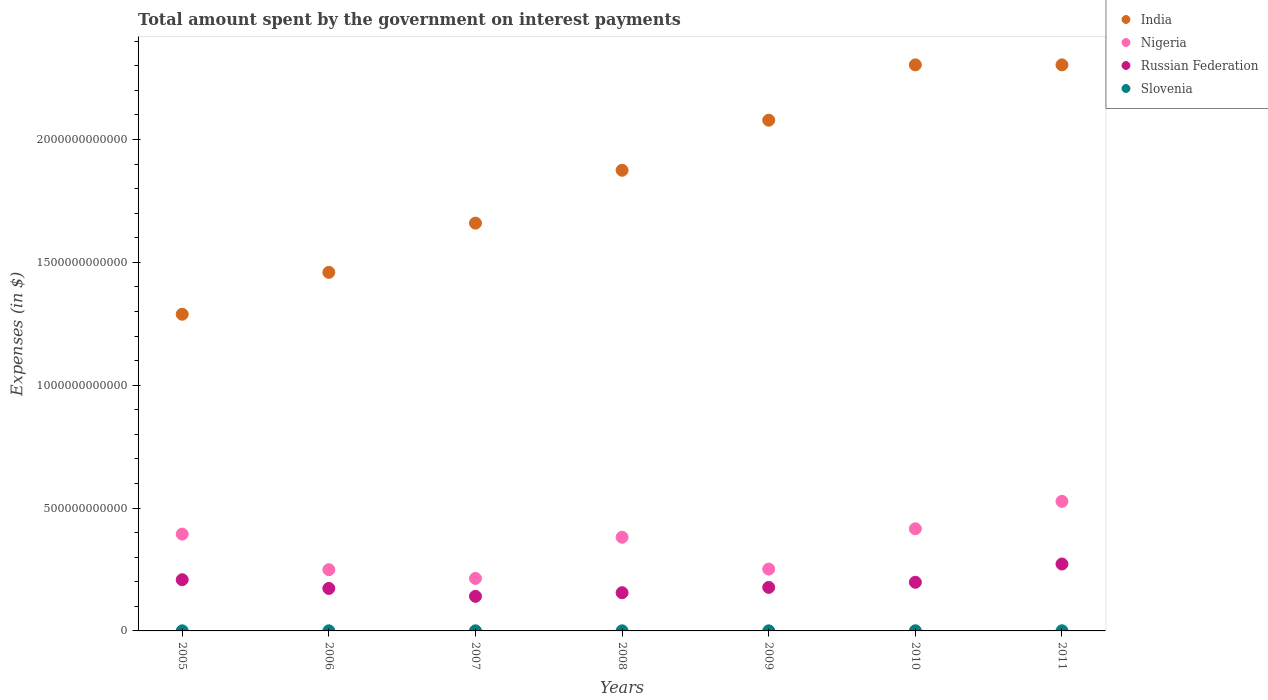How many different coloured dotlines are there?
Your answer should be very brief. 4. Is the number of dotlines equal to the number of legend labels?
Give a very brief answer. Yes. What is the amount spent on interest payments by the government in Russian Federation in 2011?
Offer a very short reply. 2.72e+11. Across all years, what is the maximum amount spent on interest payments by the government in India?
Keep it short and to the point. 2.30e+12. Across all years, what is the minimum amount spent on interest payments by the government in Russian Federation?
Provide a succinct answer. 1.41e+11. In which year was the amount spent on interest payments by the government in Nigeria maximum?
Ensure brevity in your answer.  2011. What is the total amount spent on interest payments by the government in India in the graph?
Offer a very short reply. 1.30e+13. What is the difference between the amount spent on interest payments by the government in Nigeria in 2005 and that in 2010?
Offer a very short reply. -2.17e+1. What is the difference between the amount spent on interest payments by the government in Nigeria in 2006 and the amount spent on interest payments by the government in Slovenia in 2010?
Ensure brevity in your answer.  2.49e+11. What is the average amount spent on interest payments by the government in India per year?
Offer a very short reply. 1.85e+12. In the year 2009, what is the difference between the amount spent on interest payments by the government in Russian Federation and amount spent on interest payments by the government in Slovenia?
Provide a succinct answer. 1.77e+11. In how many years, is the amount spent on interest payments by the government in Nigeria greater than 1300000000000 $?
Keep it short and to the point. 0. What is the ratio of the amount spent on interest payments by the government in Russian Federation in 2005 to that in 2007?
Provide a succinct answer. 1.48. Is the difference between the amount spent on interest payments by the government in Russian Federation in 2005 and 2009 greater than the difference between the amount spent on interest payments by the government in Slovenia in 2005 and 2009?
Your answer should be very brief. Yes. What is the difference between the highest and the second highest amount spent on interest payments by the government in India?
Keep it short and to the point. 0. What is the difference between the highest and the lowest amount spent on interest payments by the government in India?
Provide a succinct answer. 1.01e+12. In how many years, is the amount spent on interest payments by the government in Nigeria greater than the average amount spent on interest payments by the government in Nigeria taken over all years?
Provide a short and direct response. 4. Does the amount spent on interest payments by the government in Russian Federation monotonically increase over the years?
Provide a succinct answer. No. Is the amount spent on interest payments by the government in India strictly greater than the amount spent on interest payments by the government in Slovenia over the years?
Give a very brief answer. Yes. Is the amount spent on interest payments by the government in India strictly less than the amount spent on interest payments by the government in Nigeria over the years?
Offer a terse response. No. What is the difference between two consecutive major ticks on the Y-axis?
Offer a very short reply. 5.00e+11. Where does the legend appear in the graph?
Your response must be concise. Top right. How many legend labels are there?
Your answer should be compact. 4. What is the title of the graph?
Your response must be concise. Total amount spent by the government on interest payments. Does "Bahrain" appear as one of the legend labels in the graph?
Your response must be concise. No. What is the label or title of the X-axis?
Keep it short and to the point. Years. What is the label or title of the Y-axis?
Ensure brevity in your answer.  Expenses (in $). What is the Expenses (in $) in India in 2005?
Make the answer very short. 1.29e+12. What is the Expenses (in $) in Nigeria in 2005?
Give a very brief answer. 3.94e+11. What is the Expenses (in $) of Russian Federation in 2005?
Provide a short and direct response. 2.08e+11. What is the Expenses (in $) of Slovenia in 2005?
Ensure brevity in your answer.  4.55e+08. What is the Expenses (in $) of India in 2006?
Your answer should be very brief. 1.46e+12. What is the Expenses (in $) in Nigeria in 2006?
Provide a succinct answer. 2.49e+11. What is the Expenses (in $) in Russian Federation in 2006?
Offer a very short reply. 1.73e+11. What is the Expenses (in $) of Slovenia in 2006?
Your answer should be very brief. 4.58e+08. What is the Expenses (in $) of India in 2007?
Give a very brief answer. 1.66e+12. What is the Expenses (in $) of Nigeria in 2007?
Make the answer very short. 2.14e+11. What is the Expenses (in $) of Russian Federation in 2007?
Make the answer very short. 1.41e+11. What is the Expenses (in $) in Slovenia in 2007?
Keep it short and to the point. 4.34e+08. What is the Expenses (in $) of India in 2008?
Provide a succinct answer. 1.87e+12. What is the Expenses (in $) in Nigeria in 2008?
Your answer should be compact. 3.81e+11. What is the Expenses (in $) in Russian Federation in 2008?
Your answer should be compact. 1.56e+11. What is the Expenses (in $) of Slovenia in 2008?
Your answer should be very brief. 4.04e+08. What is the Expenses (in $) of India in 2009?
Keep it short and to the point. 2.08e+12. What is the Expenses (in $) of Nigeria in 2009?
Your response must be concise. 2.52e+11. What is the Expenses (in $) of Russian Federation in 2009?
Keep it short and to the point. 1.77e+11. What is the Expenses (in $) in Slovenia in 2009?
Offer a very short reply. 3.96e+08. What is the Expenses (in $) of India in 2010?
Your answer should be compact. 2.30e+12. What is the Expenses (in $) in Nigeria in 2010?
Offer a very short reply. 4.16e+11. What is the Expenses (in $) of Russian Federation in 2010?
Keep it short and to the point. 1.98e+11. What is the Expenses (in $) in Slovenia in 2010?
Your answer should be very brief. 5.44e+08. What is the Expenses (in $) of India in 2011?
Ensure brevity in your answer.  2.30e+12. What is the Expenses (in $) of Nigeria in 2011?
Provide a short and direct response. 5.27e+11. What is the Expenses (in $) in Russian Federation in 2011?
Provide a succinct answer. 2.72e+11. What is the Expenses (in $) of Slovenia in 2011?
Your response must be concise. 5.61e+08. Across all years, what is the maximum Expenses (in $) in India?
Give a very brief answer. 2.30e+12. Across all years, what is the maximum Expenses (in $) in Nigeria?
Offer a very short reply. 5.27e+11. Across all years, what is the maximum Expenses (in $) in Russian Federation?
Your response must be concise. 2.72e+11. Across all years, what is the maximum Expenses (in $) in Slovenia?
Provide a succinct answer. 5.61e+08. Across all years, what is the minimum Expenses (in $) in India?
Make the answer very short. 1.29e+12. Across all years, what is the minimum Expenses (in $) of Nigeria?
Keep it short and to the point. 2.14e+11. Across all years, what is the minimum Expenses (in $) in Russian Federation?
Give a very brief answer. 1.41e+11. Across all years, what is the minimum Expenses (in $) in Slovenia?
Your answer should be compact. 3.96e+08. What is the total Expenses (in $) in India in the graph?
Your answer should be very brief. 1.30e+13. What is the total Expenses (in $) of Nigeria in the graph?
Keep it short and to the point. 2.43e+12. What is the total Expenses (in $) in Russian Federation in the graph?
Offer a terse response. 1.32e+12. What is the total Expenses (in $) in Slovenia in the graph?
Provide a short and direct response. 3.25e+09. What is the difference between the Expenses (in $) in India in 2005 and that in 2006?
Make the answer very short. -1.70e+11. What is the difference between the Expenses (in $) in Nigeria in 2005 and that in 2006?
Ensure brevity in your answer.  1.45e+11. What is the difference between the Expenses (in $) of Russian Federation in 2005 and that in 2006?
Provide a succinct answer. 3.54e+1. What is the difference between the Expenses (in $) of Slovenia in 2005 and that in 2006?
Offer a terse response. -2.91e+06. What is the difference between the Expenses (in $) of India in 2005 and that in 2007?
Ensure brevity in your answer.  -3.71e+11. What is the difference between the Expenses (in $) of Nigeria in 2005 and that in 2007?
Offer a very short reply. 1.80e+11. What is the difference between the Expenses (in $) of Russian Federation in 2005 and that in 2007?
Ensure brevity in your answer.  6.76e+1. What is the difference between the Expenses (in $) of Slovenia in 2005 and that in 2007?
Offer a very short reply. 2.12e+07. What is the difference between the Expenses (in $) in India in 2005 and that in 2008?
Offer a terse response. -5.86e+11. What is the difference between the Expenses (in $) in Nigeria in 2005 and that in 2008?
Provide a succinct answer. 1.28e+1. What is the difference between the Expenses (in $) in Russian Federation in 2005 and that in 2008?
Give a very brief answer. 5.28e+1. What is the difference between the Expenses (in $) in Slovenia in 2005 and that in 2008?
Your answer should be very brief. 5.09e+07. What is the difference between the Expenses (in $) of India in 2005 and that in 2009?
Provide a succinct answer. -7.90e+11. What is the difference between the Expenses (in $) of Nigeria in 2005 and that in 2009?
Make the answer very short. 1.42e+11. What is the difference between the Expenses (in $) of Russian Federation in 2005 and that in 2009?
Make the answer very short. 3.12e+1. What is the difference between the Expenses (in $) in Slovenia in 2005 and that in 2009?
Your answer should be compact. 5.91e+07. What is the difference between the Expenses (in $) of India in 2005 and that in 2010?
Provide a short and direct response. -1.01e+12. What is the difference between the Expenses (in $) in Nigeria in 2005 and that in 2010?
Your answer should be very brief. -2.17e+1. What is the difference between the Expenses (in $) of Russian Federation in 2005 and that in 2010?
Your response must be concise. 1.03e+1. What is the difference between the Expenses (in $) in Slovenia in 2005 and that in 2010?
Keep it short and to the point. -8.94e+07. What is the difference between the Expenses (in $) in India in 2005 and that in 2011?
Your answer should be compact. -1.01e+12. What is the difference between the Expenses (in $) in Nigeria in 2005 and that in 2011?
Your response must be concise. -1.33e+11. What is the difference between the Expenses (in $) in Russian Federation in 2005 and that in 2011?
Keep it short and to the point. -6.40e+1. What is the difference between the Expenses (in $) in Slovenia in 2005 and that in 2011?
Your answer should be very brief. -1.06e+08. What is the difference between the Expenses (in $) of India in 2006 and that in 2007?
Keep it short and to the point. -2.00e+11. What is the difference between the Expenses (in $) of Nigeria in 2006 and that in 2007?
Your response must be concise. 3.56e+1. What is the difference between the Expenses (in $) of Russian Federation in 2006 and that in 2007?
Provide a short and direct response. 3.22e+1. What is the difference between the Expenses (in $) of Slovenia in 2006 and that in 2007?
Ensure brevity in your answer.  2.41e+07. What is the difference between the Expenses (in $) in India in 2006 and that in 2008?
Provide a short and direct response. -4.16e+11. What is the difference between the Expenses (in $) in Nigeria in 2006 and that in 2008?
Your answer should be compact. -1.32e+11. What is the difference between the Expenses (in $) in Russian Federation in 2006 and that in 2008?
Offer a very short reply. 1.74e+1. What is the difference between the Expenses (in $) of Slovenia in 2006 and that in 2008?
Make the answer very short. 5.38e+07. What is the difference between the Expenses (in $) in India in 2006 and that in 2009?
Offer a very short reply. -6.19e+11. What is the difference between the Expenses (in $) of Nigeria in 2006 and that in 2009?
Give a very brief answer. -2.40e+09. What is the difference between the Expenses (in $) of Russian Federation in 2006 and that in 2009?
Provide a succinct answer. -4.20e+09. What is the difference between the Expenses (in $) in Slovenia in 2006 and that in 2009?
Your response must be concise. 6.20e+07. What is the difference between the Expenses (in $) of India in 2006 and that in 2010?
Ensure brevity in your answer.  -8.44e+11. What is the difference between the Expenses (in $) in Nigeria in 2006 and that in 2010?
Your answer should be very brief. -1.66e+11. What is the difference between the Expenses (in $) in Russian Federation in 2006 and that in 2010?
Your response must be concise. -2.51e+1. What is the difference between the Expenses (in $) in Slovenia in 2006 and that in 2010?
Make the answer very short. -8.65e+07. What is the difference between the Expenses (in $) of India in 2006 and that in 2011?
Keep it short and to the point. -8.44e+11. What is the difference between the Expenses (in $) of Nigeria in 2006 and that in 2011?
Ensure brevity in your answer.  -2.78e+11. What is the difference between the Expenses (in $) in Russian Federation in 2006 and that in 2011?
Make the answer very short. -9.94e+1. What is the difference between the Expenses (in $) in Slovenia in 2006 and that in 2011?
Offer a very short reply. -1.03e+08. What is the difference between the Expenses (in $) in India in 2007 and that in 2008?
Offer a terse response. -2.15e+11. What is the difference between the Expenses (in $) of Nigeria in 2007 and that in 2008?
Provide a succinct answer. -1.68e+11. What is the difference between the Expenses (in $) of Russian Federation in 2007 and that in 2008?
Offer a very short reply. -1.48e+1. What is the difference between the Expenses (in $) of Slovenia in 2007 and that in 2008?
Your answer should be very brief. 2.97e+07. What is the difference between the Expenses (in $) in India in 2007 and that in 2009?
Your answer should be very brief. -4.19e+11. What is the difference between the Expenses (in $) in Nigeria in 2007 and that in 2009?
Keep it short and to the point. -3.80e+1. What is the difference between the Expenses (in $) in Russian Federation in 2007 and that in 2009?
Your answer should be compact. -3.64e+1. What is the difference between the Expenses (in $) of Slovenia in 2007 and that in 2009?
Your response must be concise. 3.79e+07. What is the difference between the Expenses (in $) of India in 2007 and that in 2010?
Your answer should be compact. -6.44e+11. What is the difference between the Expenses (in $) in Nigeria in 2007 and that in 2010?
Provide a succinct answer. -2.02e+11. What is the difference between the Expenses (in $) of Russian Federation in 2007 and that in 2010?
Make the answer very short. -5.73e+1. What is the difference between the Expenses (in $) in Slovenia in 2007 and that in 2010?
Your response must be concise. -1.11e+08. What is the difference between the Expenses (in $) in India in 2007 and that in 2011?
Provide a succinct answer. -6.44e+11. What is the difference between the Expenses (in $) of Nigeria in 2007 and that in 2011?
Offer a terse response. -3.14e+11. What is the difference between the Expenses (in $) of Russian Federation in 2007 and that in 2011?
Make the answer very short. -1.32e+11. What is the difference between the Expenses (in $) of Slovenia in 2007 and that in 2011?
Offer a very short reply. -1.27e+08. What is the difference between the Expenses (in $) of India in 2008 and that in 2009?
Your response must be concise. -2.04e+11. What is the difference between the Expenses (in $) in Nigeria in 2008 and that in 2009?
Ensure brevity in your answer.  1.30e+11. What is the difference between the Expenses (in $) of Russian Federation in 2008 and that in 2009?
Ensure brevity in your answer.  -2.16e+1. What is the difference between the Expenses (in $) of Slovenia in 2008 and that in 2009?
Keep it short and to the point. 8.23e+06. What is the difference between the Expenses (in $) of India in 2008 and that in 2010?
Make the answer very short. -4.29e+11. What is the difference between the Expenses (in $) in Nigeria in 2008 and that in 2010?
Your response must be concise. -3.45e+1. What is the difference between the Expenses (in $) of Russian Federation in 2008 and that in 2010?
Your answer should be compact. -4.25e+1. What is the difference between the Expenses (in $) in Slovenia in 2008 and that in 2010?
Your answer should be very brief. -1.40e+08. What is the difference between the Expenses (in $) of India in 2008 and that in 2011?
Your answer should be compact. -4.29e+11. What is the difference between the Expenses (in $) in Nigeria in 2008 and that in 2011?
Ensure brevity in your answer.  -1.46e+11. What is the difference between the Expenses (in $) in Russian Federation in 2008 and that in 2011?
Make the answer very short. -1.17e+11. What is the difference between the Expenses (in $) in Slovenia in 2008 and that in 2011?
Provide a short and direct response. -1.57e+08. What is the difference between the Expenses (in $) in India in 2009 and that in 2010?
Make the answer very short. -2.25e+11. What is the difference between the Expenses (in $) of Nigeria in 2009 and that in 2010?
Your answer should be very brief. -1.64e+11. What is the difference between the Expenses (in $) in Russian Federation in 2009 and that in 2010?
Your answer should be compact. -2.09e+1. What is the difference between the Expenses (in $) in Slovenia in 2009 and that in 2010?
Give a very brief answer. -1.49e+08. What is the difference between the Expenses (in $) of India in 2009 and that in 2011?
Make the answer very short. -2.25e+11. What is the difference between the Expenses (in $) in Nigeria in 2009 and that in 2011?
Your response must be concise. -2.76e+11. What is the difference between the Expenses (in $) in Russian Federation in 2009 and that in 2011?
Keep it short and to the point. -9.52e+1. What is the difference between the Expenses (in $) in Slovenia in 2009 and that in 2011?
Ensure brevity in your answer.  -1.65e+08. What is the difference between the Expenses (in $) of Nigeria in 2010 and that in 2011?
Offer a terse response. -1.12e+11. What is the difference between the Expenses (in $) in Russian Federation in 2010 and that in 2011?
Provide a short and direct response. -7.43e+1. What is the difference between the Expenses (in $) in Slovenia in 2010 and that in 2011?
Your answer should be compact. -1.68e+07. What is the difference between the Expenses (in $) in India in 2005 and the Expenses (in $) in Nigeria in 2006?
Provide a succinct answer. 1.04e+12. What is the difference between the Expenses (in $) in India in 2005 and the Expenses (in $) in Russian Federation in 2006?
Your answer should be very brief. 1.12e+12. What is the difference between the Expenses (in $) of India in 2005 and the Expenses (in $) of Slovenia in 2006?
Make the answer very short. 1.29e+12. What is the difference between the Expenses (in $) in Nigeria in 2005 and the Expenses (in $) in Russian Federation in 2006?
Ensure brevity in your answer.  2.21e+11. What is the difference between the Expenses (in $) in Nigeria in 2005 and the Expenses (in $) in Slovenia in 2006?
Your answer should be very brief. 3.94e+11. What is the difference between the Expenses (in $) in Russian Federation in 2005 and the Expenses (in $) in Slovenia in 2006?
Keep it short and to the point. 2.08e+11. What is the difference between the Expenses (in $) in India in 2005 and the Expenses (in $) in Nigeria in 2007?
Make the answer very short. 1.07e+12. What is the difference between the Expenses (in $) in India in 2005 and the Expenses (in $) in Russian Federation in 2007?
Make the answer very short. 1.15e+12. What is the difference between the Expenses (in $) of India in 2005 and the Expenses (in $) of Slovenia in 2007?
Provide a succinct answer. 1.29e+12. What is the difference between the Expenses (in $) of Nigeria in 2005 and the Expenses (in $) of Russian Federation in 2007?
Your answer should be compact. 2.53e+11. What is the difference between the Expenses (in $) of Nigeria in 2005 and the Expenses (in $) of Slovenia in 2007?
Your response must be concise. 3.94e+11. What is the difference between the Expenses (in $) of Russian Federation in 2005 and the Expenses (in $) of Slovenia in 2007?
Your answer should be compact. 2.08e+11. What is the difference between the Expenses (in $) of India in 2005 and the Expenses (in $) of Nigeria in 2008?
Make the answer very short. 9.07e+11. What is the difference between the Expenses (in $) in India in 2005 and the Expenses (in $) in Russian Federation in 2008?
Your answer should be compact. 1.13e+12. What is the difference between the Expenses (in $) of India in 2005 and the Expenses (in $) of Slovenia in 2008?
Your answer should be compact. 1.29e+12. What is the difference between the Expenses (in $) in Nigeria in 2005 and the Expenses (in $) in Russian Federation in 2008?
Provide a short and direct response. 2.38e+11. What is the difference between the Expenses (in $) of Nigeria in 2005 and the Expenses (in $) of Slovenia in 2008?
Your response must be concise. 3.94e+11. What is the difference between the Expenses (in $) of Russian Federation in 2005 and the Expenses (in $) of Slovenia in 2008?
Ensure brevity in your answer.  2.08e+11. What is the difference between the Expenses (in $) in India in 2005 and the Expenses (in $) in Nigeria in 2009?
Provide a short and direct response. 1.04e+12. What is the difference between the Expenses (in $) in India in 2005 and the Expenses (in $) in Russian Federation in 2009?
Your answer should be compact. 1.11e+12. What is the difference between the Expenses (in $) in India in 2005 and the Expenses (in $) in Slovenia in 2009?
Offer a terse response. 1.29e+12. What is the difference between the Expenses (in $) in Nigeria in 2005 and the Expenses (in $) in Russian Federation in 2009?
Provide a succinct answer. 2.17e+11. What is the difference between the Expenses (in $) of Nigeria in 2005 and the Expenses (in $) of Slovenia in 2009?
Offer a terse response. 3.94e+11. What is the difference between the Expenses (in $) of Russian Federation in 2005 and the Expenses (in $) of Slovenia in 2009?
Your response must be concise. 2.08e+11. What is the difference between the Expenses (in $) of India in 2005 and the Expenses (in $) of Nigeria in 2010?
Offer a very short reply. 8.73e+11. What is the difference between the Expenses (in $) of India in 2005 and the Expenses (in $) of Russian Federation in 2010?
Your answer should be compact. 1.09e+12. What is the difference between the Expenses (in $) of India in 2005 and the Expenses (in $) of Slovenia in 2010?
Your response must be concise. 1.29e+12. What is the difference between the Expenses (in $) of Nigeria in 2005 and the Expenses (in $) of Russian Federation in 2010?
Keep it short and to the point. 1.96e+11. What is the difference between the Expenses (in $) of Nigeria in 2005 and the Expenses (in $) of Slovenia in 2010?
Your answer should be compact. 3.93e+11. What is the difference between the Expenses (in $) of Russian Federation in 2005 and the Expenses (in $) of Slovenia in 2010?
Offer a terse response. 2.08e+11. What is the difference between the Expenses (in $) of India in 2005 and the Expenses (in $) of Nigeria in 2011?
Offer a terse response. 7.61e+11. What is the difference between the Expenses (in $) in India in 2005 and the Expenses (in $) in Russian Federation in 2011?
Offer a terse response. 1.02e+12. What is the difference between the Expenses (in $) of India in 2005 and the Expenses (in $) of Slovenia in 2011?
Keep it short and to the point. 1.29e+12. What is the difference between the Expenses (in $) of Nigeria in 2005 and the Expenses (in $) of Russian Federation in 2011?
Your answer should be compact. 1.22e+11. What is the difference between the Expenses (in $) in Nigeria in 2005 and the Expenses (in $) in Slovenia in 2011?
Your answer should be very brief. 3.93e+11. What is the difference between the Expenses (in $) of Russian Federation in 2005 and the Expenses (in $) of Slovenia in 2011?
Provide a succinct answer. 2.08e+11. What is the difference between the Expenses (in $) in India in 2006 and the Expenses (in $) in Nigeria in 2007?
Your answer should be very brief. 1.25e+12. What is the difference between the Expenses (in $) of India in 2006 and the Expenses (in $) of Russian Federation in 2007?
Give a very brief answer. 1.32e+12. What is the difference between the Expenses (in $) in India in 2006 and the Expenses (in $) in Slovenia in 2007?
Give a very brief answer. 1.46e+12. What is the difference between the Expenses (in $) in Nigeria in 2006 and the Expenses (in $) in Russian Federation in 2007?
Provide a short and direct response. 1.09e+11. What is the difference between the Expenses (in $) of Nigeria in 2006 and the Expenses (in $) of Slovenia in 2007?
Offer a terse response. 2.49e+11. What is the difference between the Expenses (in $) of Russian Federation in 2006 and the Expenses (in $) of Slovenia in 2007?
Offer a very short reply. 1.72e+11. What is the difference between the Expenses (in $) in India in 2006 and the Expenses (in $) in Nigeria in 2008?
Keep it short and to the point. 1.08e+12. What is the difference between the Expenses (in $) of India in 2006 and the Expenses (in $) of Russian Federation in 2008?
Your answer should be compact. 1.30e+12. What is the difference between the Expenses (in $) in India in 2006 and the Expenses (in $) in Slovenia in 2008?
Your answer should be very brief. 1.46e+12. What is the difference between the Expenses (in $) of Nigeria in 2006 and the Expenses (in $) of Russian Federation in 2008?
Your answer should be compact. 9.38e+1. What is the difference between the Expenses (in $) of Nigeria in 2006 and the Expenses (in $) of Slovenia in 2008?
Keep it short and to the point. 2.49e+11. What is the difference between the Expenses (in $) in Russian Federation in 2006 and the Expenses (in $) in Slovenia in 2008?
Offer a very short reply. 1.72e+11. What is the difference between the Expenses (in $) of India in 2006 and the Expenses (in $) of Nigeria in 2009?
Your answer should be very brief. 1.21e+12. What is the difference between the Expenses (in $) of India in 2006 and the Expenses (in $) of Russian Federation in 2009?
Offer a very short reply. 1.28e+12. What is the difference between the Expenses (in $) of India in 2006 and the Expenses (in $) of Slovenia in 2009?
Make the answer very short. 1.46e+12. What is the difference between the Expenses (in $) of Nigeria in 2006 and the Expenses (in $) of Russian Federation in 2009?
Make the answer very short. 7.22e+1. What is the difference between the Expenses (in $) of Nigeria in 2006 and the Expenses (in $) of Slovenia in 2009?
Keep it short and to the point. 2.49e+11. What is the difference between the Expenses (in $) of Russian Federation in 2006 and the Expenses (in $) of Slovenia in 2009?
Provide a succinct answer. 1.73e+11. What is the difference between the Expenses (in $) of India in 2006 and the Expenses (in $) of Nigeria in 2010?
Offer a terse response. 1.04e+12. What is the difference between the Expenses (in $) of India in 2006 and the Expenses (in $) of Russian Federation in 2010?
Keep it short and to the point. 1.26e+12. What is the difference between the Expenses (in $) in India in 2006 and the Expenses (in $) in Slovenia in 2010?
Keep it short and to the point. 1.46e+12. What is the difference between the Expenses (in $) of Nigeria in 2006 and the Expenses (in $) of Russian Federation in 2010?
Offer a terse response. 5.13e+1. What is the difference between the Expenses (in $) in Nigeria in 2006 and the Expenses (in $) in Slovenia in 2010?
Your response must be concise. 2.49e+11. What is the difference between the Expenses (in $) of Russian Federation in 2006 and the Expenses (in $) of Slovenia in 2010?
Offer a terse response. 1.72e+11. What is the difference between the Expenses (in $) in India in 2006 and the Expenses (in $) in Nigeria in 2011?
Offer a terse response. 9.32e+11. What is the difference between the Expenses (in $) of India in 2006 and the Expenses (in $) of Russian Federation in 2011?
Your response must be concise. 1.19e+12. What is the difference between the Expenses (in $) of India in 2006 and the Expenses (in $) of Slovenia in 2011?
Offer a very short reply. 1.46e+12. What is the difference between the Expenses (in $) in Nigeria in 2006 and the Expenses (in $) in Russian Federation in 2011?
Keep it short and to the point. -2.30e+1. What is the difference between the Expenses (in $) of Nigeria in 2006 and the Expenses (in $) of Slovenia in 2011?
Provide a short and direct response. 2.49e+11. What is the difference between the Expenses (in $) of Russian Federation in 2006 and the Expenses (in $) of Slovenia in 2011?
Your response must be concise. 1.72e+11. What is the difference between the Expenses (in $) in India in 2007 and the Expenses (in $) in Nigeria in 2008?
Offer a terse response. 1.28e+12. What is the difference between the Expenses (in $) of India in 2007 and the Expenses (in $) of Russian Federation in 2008?
Make the answer very short. 1.50e+12. What is the difference between the Expenses (in $) in India in 2007 and the Expenses (in $) in Slovenia in 2008?
Provide a short and direct response. 1.66e+12. What is the difference between the Expenses (in $) of Nigeria in 2007 and the Expenses (in $) of Russian Federation in 2008?
Provide a short and direct response. 5.82e+1. What is the difference between the Expenses (in $) of Nigeria in 2007 and the Expenses (in $) of Slovenia in 2008?
Make the answer very short. 2.13e+11. What is the difference between the Expenses (in $) in Russian Federation in 2007 and the Expenses (in $) in Slovenia in 2008?
Give a very brief answer. 1.40e+11. What is the difference between the Expenses (in $) of India in 2007 and the Expenses (in $) of Nigeria in 2009?
Your response must be concise. 1.41e+12. What is the difference between the Expenses (in $) of India in 2007 and the Expenses (in $) of Russian Federation in 2009?
Offer a terse response. 1.48e+12. What is the difference between the Expenses (in $) of India in 2007 and the Expenses (in $) of Slovenia in 2009?
Make the answer very short. 1.66e+12. What is the difference between the Expenses (in $) of Nigeria in 2007 and the Expenses (in $) of Russian Federation in 2009?
Ensure brevity in your answer.  3.66e+1. What is the difference between the Expenses (in $) in Nigeria in 2007 and the Expenses (in $) in Slovenia in 2009?
Your response must be concise. 2.13e+11. What is the difference between the Expenses (in $) in Russian Federation in 2007 and the Expenses (in $) in Slovenia in 2009?
Give a very brief answer. 1.40e+11. What is the difference between the Expenses (in $) of India in 2007 and the Expenses (in $) of Nigeria in 2010?
Your response must be concise. 1.24e+12. What is the difference between the Expenses (in $) in India in 2007 and the Expenses (in $) in Russian Federation in 2010?
Provide a short and direct response. 1.46e+12. What is the difference between the Expenses (in $) of India in 2007 and the Expenses (in $) of Slovenia in 2010?
Give a very brief answer. 1.66e+12. What is the difference between the Expenses (in $) in Nigeria in 2007 and the Expenses (in $) in Russian Federation in 2010?
Your answer should be compact. 1.57e+1. What is the difference between the Expenses (in $) in Nigeria in 2007 and the Expenses (in $) in Slovenia in 2010?
Ensure brevity in your answer.  2.13e+11. What is the difference between the Expenses (in $) in Russian Federation in 2007 and the Expenses (in $) in Slovenia in 2010?
Ensure brevity in your answer.  1.40e+11. What is the difference between the Expenses (in $) in India in 2007 and the Expenses (in $) in Nigeria in 2011?
Your response must be concise. 1.13e+12. What is the difference between the Expenses (in $) in India in 2007 and the Expenses (in $) in Russian Federation in 2011?
Ensure brevity in your answer.  1.39e+12. What is the difference between the Expenses (in $) of India in 2007 and the Expenses (in $) of Slovenia in 2011?
Your answer should be very brief. 1.66e+12. What is the difference between the Expenses (in $) in Nigeria in 2007 and the Expenses (in $) in Russian Federation in 2011?
Provide a succinct answer. -5.86e+1. What is the difference between the Expenses (in $) of Nigeria in 2007 and the Expenses (in $) of Slovenia in 2011?
Keep it short and to the point. 2.13e+11. What is the difference between the Expenses (in $) of Russian Federation in 2007 and the Expenses (in $) of Slovenia in 2011?
Your answer should be very brief. 1.40e+11. What is the difference between the Expenses (in $) in India in 2008 and the Expenses (in $) in Nigeria in 2009?
Your answer should be very brief. 1.62e+12. What is the difference between the Expenses (in $) in India in 2008 and the Expenses (in $) in Russian Federation in 2009?
Your answer should be compact. 1.70e+12. What is the difference between the Expenses (in $) in India in 2008 and the Expenses (in $) in Slovenia in 2009?
Provide a short and direct response. 1.87e+12. What is the difference between the Expenses (in $) of Nigeria in 2008 and the Expenses (in $) of Russian Federation in 2009?
Your response must be concise. 2.04e+11. What is the difference between the Expenses (in $) of Nigeria in 2008 and the Expenses (in $) of Slovenia in 2009?
Offer a terse response. 3.81e+11. What is the difference between the Expenses (in $) of Russian Federation in 2008 and the Expenses (in $) of Slovenia in 2009?
Give a very brief answer. 1.55e+11. What is the difference between the Expenses (in $) of India in 2008 and the Expenses (in $) of Nigeria in 2010?
Make the answer very short. 1.46e+12. What is the difference between the Expenses (in $) in India in 2008 and the Expenses (in $) in Russian Federation in 2010?
Provide a short and direct response. 1.68e+12. What is the difference between the Expenses (in $) of India in 2008 and the Expenses (in $) of Slovenia in 2010?
Offer a very short reply. 1.87e+12. What is the difference between the Expenses (in $) in Nigeria in 2008 and the Expenses (in $) in Russian Federation in 2010?
Your answer should be compact. 1.83e+11. What is the difference between the Expenses (in $) in Nigeria in 2008 and the Expenses (in $) in Slovenia in 2010?
Ensure brevity in your answer.  3.81e+11. What is the difference between the Expenses (in $) in Russian Federation in 2008 and the Expenses (in $) in Slovenia in 2010?
Make the answer very short. 1.55e+11. What is the difference between the Expenses (in $) of India in 2008 and the Expenses (in $) of Nigeria in 2011?
Offer a terse response. 1.35e+12. What is the difference between the Expenses (in $) in India in 2008 and the Expenses (in $) in Russian Federation in 2011?
Your response must be concise. 1.60e+12. What is the difference between the Expenses (in $) of India in 2008 and the Expenses (in $) of Slovenia in 2011?
Provide a succinct answer. 1.87e+12. What is the difference between the Expenses (in $) of Nigeria in 2008 and the Expenses (in $) of Russian Federation in 2011?
Your answer should be very brief. 1.09e+11. What is the difference between the Expenses (in $) in Nigeria in 2008 and the Expenses (in $) in Slovenia in 2011?
Offer a very short reply. 3.81e+11. What is the difference between the Expenses (in $) in Russian Federation in 2008 and the Expenses (in $) in Slovenia in 2011?
Your answer should be compact. 1.55e+11. What is the difference between the Expenses (in $) in India in 2009 and the Expenses (in $) in Nigeria in 2010?
Keep it short and to the point. 1.66e+12. What is the difference between the Expenses (in $) of India in 2009 and the Expenses (in $) of Russian Federation in 2010?
Offer a terse response. 1.88e+12. What is the difference between the Expenses (in $) in India in 2009 and the Expenses (in $) in Slovenia in 2010?
Your response must be concise. 2.08e+12. What is the difference between the Expenses (in $) in Nigeria in 2009 and the Expenses (in $) in Russian Federation in 2010?
Offer a terse response. 5.37e+1. What is the difference between the Expenses (in $) of Nigeria in 2009 and the Expenses (in $) of Slovenia in 2010?
Provide a short and direct response. 2.51e+11. What is the difference between the Expenses (in $) of Russian Federation in 2009 and the Expenses (in $) of Slovenia in 2010?
Offer a terse response. 1.77e+11. What is the difference between the Expenses (in $) in India in 2009 and the Expenses (in $) in Nigeria in 2011?
Provide a short and direct response. 1.55e+12. What is the difference between the Expenses (in $) in India in 2009 and the Expenses (in $) in Russian Federation in 2011?
Offer a very short reply. 1.81e+12. What is the difference between the Expenses (in $) of India in 2009 and the Expenses (in $) of Slovenia in 2011?
Make the answer very short. 2.08e+12. What is the difference between the Expenses (in $) in Nigeria in 2009 and the Expenses (in $) in Russian Federation in 2011?
Offer a very short reply. -2.06e+1. What is the difference between the Expenses (in $) in Nigeria in 2009 and the Expenses (in $) in Slovenia in 2011?
Your response must be concise. 2.51e+11. What is the difference between the Expenses (in $) of Russian Federation in 2009 and the Expenses (in $) of Slovenia in 2011?
Keep it short and to the point. 1.77e+11. What is the difference between the Expenses (in $) of India in 2010 and the Expenses (in $) of Nigeria in 2011?
Give a very brief answer. 1.78e+12. What is the difference between the Expenses (in $) in India in 2010 and the Expenses (in $) in Russian Federation in 2011?
Ensure brevity in your answer.  2.03e+12. What is the difference between the Expenses (in $) of India in 2010 and the Expenses (in $) of Slovenia in 2011?
Your answer should be very brief. 2.30e+12. What is the difference between the Expenses (in $) of Nigeria in 2010 and the Expenses (in $) of Russian Federation in 2011?
Offer a very short reply. 1.43e+11. What is the difference between the Expenses (in $) in Nigeria in 2010 and the Expenses (in $) in Slovenia in 2011?
Keep it short and to the point. 4.15e+11. What is the difference between the Expenses (in $) of Russian Federation in 2010 and the Expenses (in $) of Slovenia in 2011?
Give a very brief answer. 1.97e+11. What is the average Expenses (in $) of India per year?
Make the answer very short. 1.85e+12. What is the average Expenses (in $) of Nigeria per year?
Your answer should be very brief. 3.48e+11. What is the average Expenses (in $) of Russian Federation per year?
Your response must be concise. 1.89e+11. What is the average Expenses (in $) of Slovenia per year?
Ensure brevity in your answer.  4.64e+08. In the year 2005, what is the difference between the Expenses (in $) in India and Expenses (in $) in Nigeria?
Offer a very short reply. 8.95e+11. In the year 2005, what is the difference between the Expenses (in $) of India and Expenses (in $) of Russian Federation?
Make the answer very short. 1.08e+12. In the year 2005, what is the difference between the Expenses (in $) of India and Expenses (in $) of Slovenia?
Keep it short and to the point. 1.29e+12. In the year 2005, what is the difference between the Expenses (in $) in Nigeria and Expenses (in $) in Russian Federation?
Offer a very short reply. 1.86e+11. In the year 2005, what is the difference between the Expenses (in $) of Nigeria and Expenses (in $) of Slovenia?
Your response must be concise. 3.94e+11. In the year 2005, what is the difference between the Expenses (in $) of Russian Federation and Expenses (in $) of Slovenia?
Offer a very short reply. 2.08e+11. In the year 2006, what is the difference between the Expenses (in $) of India and Expenses (in $) of Nigeria?
Make the answer very short. 1.21e+12. In the year 2006, what is the difference between the Expenses (in $) in India and Expenses (in $) in Russian Federation?
Keep it short and to the point. 1.29e+12. In the year 2006, what is the difference between the Expenses (in $) of India and Expenses (in $) of Slovenia?
Your answer should be compact. 1.46e+12. In the year 2006, what is the difference between the Expenses (in $) in Nigeria and Expenses (in $) in Russian Federation?
Keep it short and to the point. 7.64e+1. In the year 2006, what is the difference between the Expenses (in $) in Nigeria and Expenses (in $) in Slovenia?
Provide a succinct answer. 2.49e+11. In the year 2006, what is the difference between the Expenses (in $) in Russian Federation and Expenses (in $) in Slovenia?
Ensure brevity in your answer.  1.72e+11. In the year 2007, what is the difference between the Expenses (in $) of India and Expenses (in $) of Nigeria?
Your answer should be compact. 1.45e+12. In the year 2007, what is the difference between the Expenses (in $) in India and Expenses (in $) in Russian Federation?
Your answer should be compact. 1.52e+12. In the year 2007, what is the difference between the Expenses (in $) in India and Expenses (in $) in Slovenia?
Ensure brevity in your answer.  1.66e+12. In the year 2007, what is the difference between the Expenses (in $) in Nigeria and Expenses (in $) in Russian Federation?
Your answer should be compact. 7.30e+1. In the year 2007, what is the difference between the Expenses (in $) of Nigeria and Expenses (in $) of Slovenia?
Provide a succinct answer. 2.13e+11. In the year 2007, what is the difference between the Expenses (in $) of Russian Federation and Expenses (in $) of Slovenia?
Ensure brevity in your answer.  1.40e+11. In the year 2008, what is the difference between the Expenses (in $) in India and Expenses (in $) in Nigeria?
Your answer should be very brief. 1.49e+12. In the year 2008, what is the difference between the Expenses (in $) in India and Expenses (in $) in Russian Federation?
Offer a very short reply. 1.72e+12. In the year 2008, what is the difference between the Expenses (in $) of India and Expenses (in $) of Slovenia?
Your answer should be compact. 1.87e+12. In the year 2008, what is the difference between the Expenses (in $) in Nigeria and Expenses (in $) in Russian Federation?
Your response must be concise. 2.26e+11. In the year 2008, what is the difference between the Expenses (in $) of Nigeria and Expenses (in $) of Slovenia?
Offer a very short reply. 3.81e+11. In the year 2008, what is the difference between the Expenses (in $) of Russian Federation and Expenses (in $) of Slovenia?
Your answer should be compact. 1.55e+11. In the year 2009, what is the difference between the Expenses (in $) in India and Expenses (in $) in Nigeria?
Provide a short and direct response. 1.83e+12. In the year 2009, what is the difference between the Expenses (in $) of India and Expenses (in $) of Russian Federation?
Provide a short and direct response. 1.90e+12. In the year 2009, what is the difference between the Expenses (in $) in India and Expenses (in $) in Slovenia?
Make the answer very short. 2.08e+12. In the year 2009, what is the difference between the Expenses (in $) of Nigeria and Expenses (in $) of Russian Federation?
Offer a very short reply. 7.46e+1. In the year 2009, what is the difference between the Expenses (in $) in Nigeria and Expenses (in $) in Slovenia?
Provide a succinct answer. 2.51e+11. In the year 2009, what is the difference between the Expenses (in $) in Russian Federation and Expenses (in $) in Slovenia?
Your response must be concise. 1.77e+11. In the year 2010, what is the difference between the Expenses (in $) of India and Expenses (in $) of Nigeria?
Your response must be concise. 1.89e+12. In the year 2010, what is the difference between the Expenses (in $) of India and Expenses (in $) of Russian Federation?
Your answer should be compact. 2.11e+12. In the year 2010, what is the difference between the Expenses (in $) in India and Expenses (in $) in Slovenia?
Your answer should be compact. 2.30e+12. In the year 2010, what is the difference between the Expenses (in $) of Nigeria and Expenses (in $) of Russian Federation?
Make the answer very short. 2.18e+11. In the year 2010, what is the difference between the Expenses (in $) in Nigeria and Expenses (in $) in Slovenia?
Offer a very short reply. 4.15e+11. In the year 2010, what is the difference between the Expenses (in $) in Russian Federation and Expenses (in $) in Slovenia?
Your answer should be very brief. 1.97e+11. In the year 2011, what is the difference between the Expenses (in $) in India and Expenses (in $) in Nigeria?
Your response must be concise. 1.78e+12. In the year 2011, what is the difference between the Expenses (in $) in India and Expenses (in $) in Russian Federation?
Offer a terse response. 2.03e+12. In the year 2011, what is the difference between the Expenses (in $) of India and Expenses (in $) of Slovenia?
Your answer should be very brief. 2.30e+12. In the year 2011, what is the difference between the Expenses (in $) in Nigeria and Expenses (in $) in Russian Federation?
Keep it short and to the point. 2.55e+11. In the year 2011, what is the difference between the Expenses (in $) of Nigeria and Expenses (in $) of Slovenia?
Offer a terse response. 5.27e+11. In the year 2011, what is the difference between the Expenses (in $) in Russian Federation and Expenses (in $) in Slovenia?
Your answer should be very brief. 2.72e+11. What is the ratio of the Expenses (in $) of India in 2005 to that in 2006?
Give a very brief answer. 0.88. What is the ratio of the Expenses (in $) in Nigeria in 2005 to that in 2006?
Your answer should be very brief. 1.58. What is the ratio of the Expenses (in $) of Russian Federation in 2005 to that in 2006?
Ensure brevity in your answer.  1.21. What is the ratio of the Expenses (in $) of Slovenia in 2005 to that in 2006?
Ensure brevity in your answer.  0.99. What is the ratio of the Expenses (in $) in India in 2005 to that in 2007?
Give a very brief answer. 0.78. What is the ratio of the Expenses (in $) of Nigeria in 2005 to that in 2007?
Offer a terse response. 1.84. What is the ratio of the Expenses (in $) in Russian Federation in 2005 to that in 2007?
Your answer should be very brief. 1.48. What is the ratio of the Expenses (in $) in Slovenia in 2005 to that in 2007?
Give a very brief answer. 1.05. What is the ratio of the Expenses (in $) of India in 2005 to that in 2008?
Offer a terse response. 0.69. What is the ratio of the Expenses (in $) in Nigeria in 2005 to that in 2008?
Give a very brief answer. 1.03. What is the ratio of the Expenses (in $) of Russian Federation in 2005 to that in 2008?
Ensure brevity in your answer.  1.34. What is the ratio of the Expenses (in $) in Slovenia in 2005 to that in 2008?
Give a very brief answer. 1.13. What is the ratio of the Expenses (in $) in India in 2005 to that in 2009?
Offer a terse response. 0.62. What is the ratio of the Expenses (in $) of Nigeria in 2005 to that in 2009?
Give a very brief answer. 1.57. What is the ratio of the Expenses (in $) of Russian Federation in 2005 to that in 2009?
Offer a terse response. 1.18. What is the ratio of the Expenses (in $) of Slovenia in 2005 to that in 2009?
Provide a short and direct response. 1.15. What is the ratio of the Expenses (in $) of India in 2005 to that in 2010?
Provide a short and direct response. 0.56. What is the ratio of the Expenses (in $) in Nigeria in 2005 to that in 2010?
Your answer should be compact. 0.95. What is the ratio of the Expenses (in $) in Russian Federation in 2005 to that in 2010?
Your answer should be compact. 1.05. What is the ratio of the Expenses (in $) of Slovenia in 2005 to that in 2010?
Provide a succinct answer. 0.84. What is the ratio of the Expenses (in $) of India in 2005 to that in 2011?
Give a very brief answer. 0.56. What is the ratio of the Expenses (in $) of Nigeria in 2005 to that in 2011?
Provide a succinct answer. 0.75. What is the ratio of the Expenses (in $) of Russian Federation in 2005 to that in 2011?
Offer a terse response. 0.77. What is the ratio of the Expenses (in $) in Slovenia in 2005 to that in 2011?
Your answer should be compact. 0.81. What is the ratio of the Expenses (in $) in India in 2006 to that in 2007?
Give a very brief answer. 0.88. What is the ratio of the Expenses (in $) of Nigeria in 2006 to that in 2007?
Keep it short and to the point. 1.17. What is the ratio of the Expenses (in $) of Russian Federation in 2006 to that in 2007?
Make the answer very short. 1.23. What is the ratio of the Expenses (in $) of Slovenia in 2006 to that in 2007?
Provide a succinct answer. 1.06. What is the ratio of the Expenses (in $) of India in 2006 to that in 2008?
Ensure brevity in your answer.  0.78. What is the ratio of the Expenses (in $) in Nigeria in 2006 to that in 2008?
Offer a terse response. 0.65. What is the ratio of the Expenses (in $) of Russian Federation in 2006 to that in 2008?
Your answer should be very brief. 1.11. What is the ratio of the Expenses (in $) of Slovenia in 2006 to that in 2008?
Offer a very short reply. 1.13. What is the ratio of the Expenses (in $) of India in 2006 to that in 2009?
Provide a short and direct response. 0.7. What is the ratio of the Expenses (in $) in Nigeria in 2006 to that in 2009?
Give a very brief answer. 0.99. What is the ratio of the Expenses (in $) in Russian Federation in 2006 to that in 2009?
Give a very brief answer. 0.98. What is the ratio of the Expenses (in $) in Slovenia in 2006 to that in 2009?
Provide a short and direct response. 1.16. What is the ratio of the Expenses (in $) in India in 2006 to that in 2010?
Provide a succinct answer. 0.63. What is the ratio of the Expenses (in $) in Nigeria in 2006 to that in 2010?
Your answer should be compact. 0.6. What is the ratio of the Expenses (in $) of Russian Federation in 2006 to that in 2010?
Ensure brevity in your answer.  0.87. What is the ratio of the Expenses (in $) in Slovenia in 2006 to that in 2010?
Provide a short and direct response. 0.84. What is the ratio of the Expenses (in $) of India in 2006 to that in 2011?
Give a very brief answer. 0.63. What is the ratio of the Expenses (in $) in Nigeria in 2006 to that in 2011?
Offer a very short reply. 0.47. What is the ratio of the Expenses (in $) in Russian Federation in 2006 to that in 2011?
Your response must be concise. 0.64. What is the ratio of the Expenses (in $) of Slovenia in 2006 to that in 2011?
Your answer should be very brief. 0.82. What is the ratio of the Expenses (in $) of India in 2007 to that in 2008?
Make the answer very short. 0.89. What is the ratio of the Expenses (in $) of Nigeria in 2007 to that in 2008?
Make the answer very short. 0.56. What is the ratio of the Expenses (in $) in Russian Federation in 2007 to that in 2008?
Your response must be concise. 0.9. What is the ratio of the Expenses (in $) in Slovenia in 2007 to that in 2008?
Provide a short and direct response. 1.07. What is the ratio of the Expenses (in $) in India in 2007 to that in 2009?
Your response must be concise. 0.8. What is the ratio of the Expenses (in $) in Nigeria in 2007 to that in 2009?
Your answer should be compact. 0.85. What is the ratio of the Expenses (in $) in Russian Federation in 2007 to that in 2009?
Give a very brief answer. 0.79. What is the ratio of the Expenses (in $) of Slovenia in 2007 to that in 2009?
Your response must be concise. 1.1. What is the ratio of the Expenses (in $) of India in 2007 to that in 2010?
Your response must be concise. 0.72. What is the ratio of the Expenses (in $) in Nigeria in 2007 to that in 2010?
Make the answer very short. 0.51. What is the ratio of the Expenses (in $) of Russian Federation in 2007 to that in 2010?
Provide a succinct answer. 0.71. What is the ratio of the Expenses (in $) of Slovenia in 2007 to that in 2010?
Ensure brevity in your answer.  0.8. What is the ratio of the Expenses (in $) of India in 2007 to that in 2011?
Keep it short and to the point. 0.72. What is the ratio of the Expenses (in $) of Nigeria in 2007 to that in 2011?
Ensure brevity in your answer.  0.41. What is the ratio of the Expenses (in $) of Russian Federation in 2007 to that in 2011?
Give a very brief answer. 0.52. What is the ratio of the Expenses (in $) of Slovenia in 2007 to that in 2011?
Give a very brief answer. 0.77. What is the ratio of the Expenses (in $) in India in 2008 to that in 2009?
Your response must be concise. 0.9. What is the ratio of the Expenses (in $) in Nigeria in 2008 to that in 2009?
Give a very brief answer. 1.51. What is the ratio of the Expenses (in $) in Russian Federation in 2008 to that in 2009?
Keep it short and to the point. 0.88. What is the ratio of the Expenses (in $) of Slovenia in 2008 to that in 2009?
Ensure brevity in your answer.  1.02. What is the ratio of the Expenses (in $) in India in 2008 to that in 2010?
Your answer should be very brief. 0.81. What is the ratio of the Expenses (in $) of Nigeria in 2008 to that in 2010?
Your answer should be compact. 0.92. What is the ratio of the Expenses (in $) of Russian Federation in 2008 to that in 2010?
Your answer should be compact. 0.79. What is the ratio of the Expenses (in $) of Slovenia in 2008 to that in 2010?
Make the answer very short. 0.74. What is the ratio of the Expenses (in $) in India in 2008 to that in 2011?
Provide a succinct answer. 0.81. What is the ratio of the Expenses (in $) of Nigeria in 2008 to that in 2011?
Your response must be concise. 0.72. What is the ratio of the Expenses (in $) in Russian Federation in 2008 to that in 2011?
Your response must be concise. 0.57. What is the ratio of the Expenses (in $) of Slovenia in 2008 to that in 2011?
Keep it short and to the point. 0.72. What is the ratio of the Expenses (in $) in India in 2009 to that in 2010?
Your answer should be very brief. 0.9. What is the ratio of the Expenses (in $) in Nigeria in 2009 to that in 2010?
Keep it short and to the point. 0.61. What is the ratio of the Expenses (in $) of Russian Federation in 2009 to that in 2010?
Your answer should be compact. 0.89. What is the ratio of the Expenses (in $) of Slovenia in 2009 to that in 2010?
Your response must be concise. 0.73. What is the ratio of the Expenses (in $) in India in 2009 to that in 2011?
Your answer should be very brief. 0.9. What is the ratio of the Expenses (in $) of Nigeria in 2009 to that in 2011?
Ensure brevity in your answer.  0.48. What is the ratio of the Expenses (in $) of Russian Federation in 2009 to that in 2011?
Keep it short and to the point. 0.65. What is the ratio of the Expenses (in $) in Slovenia in 2009 to that in 2011?
Ensure brevity in your answer.  0.71. What is the ratio of the Expenses (in $) in India in 2010 to that in 2011?
Provide a succinct answer. 1. What is the ratio of the Expenses (in $) in Nigeria in 2010 to that in 2011?
Make the answer very short. 0.79. What is the ratio of the Expenses (in $) in Russian Federation in 2010 to that in 2011?
Your response must be concise. 0.73. What is the ratio of the Expenses (in $) of Slovenia in 2010 to that in 2011?
Make the answer very short. 0.97. What is the difference between the highest and the second highest Expenses (in $) of Nigeria?
Your answer should be compact. 1.12e+11. What is the difference between the highest and the second highest Expenses (in $) of Russian Federation?
Provide a succinct answer. 6.40e+1. What is the difference between the highest and the second highest Expenses (in $) of Slovenia?
Give a very brief answer. 1.68e+07. What is the difference between the highest and the lowest Expenses (in $) of India?
Provide a short and direct response. 1.01e+12. What is the difference between the highest and the lowest Expenses (in $) of Nigeria?
Keep it short and to the point. 3.14e+11. What is the difference between the highest and the lowest Expenses (in $) in Russian Federation?
Your answer should be compact. 1.32e+11. What is the difference between the highest and the lowest Expenses (in $) of Slovenia?
Keep it short and to the point. 1.65e+08. 